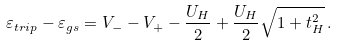Convert formula to latex. <formula><loc_0><loc_0><loc_500><loc_500>\varepsilon _ { t r i p } - \varepsilon _ { g s } = V _ { - } - V _ { + } - \frac { U _ { H } } { 2 } + \frac { U _ { H } } { 2 } \sqrt { 1 + t ^ { 2 } _ { H } } \, .</formula> 